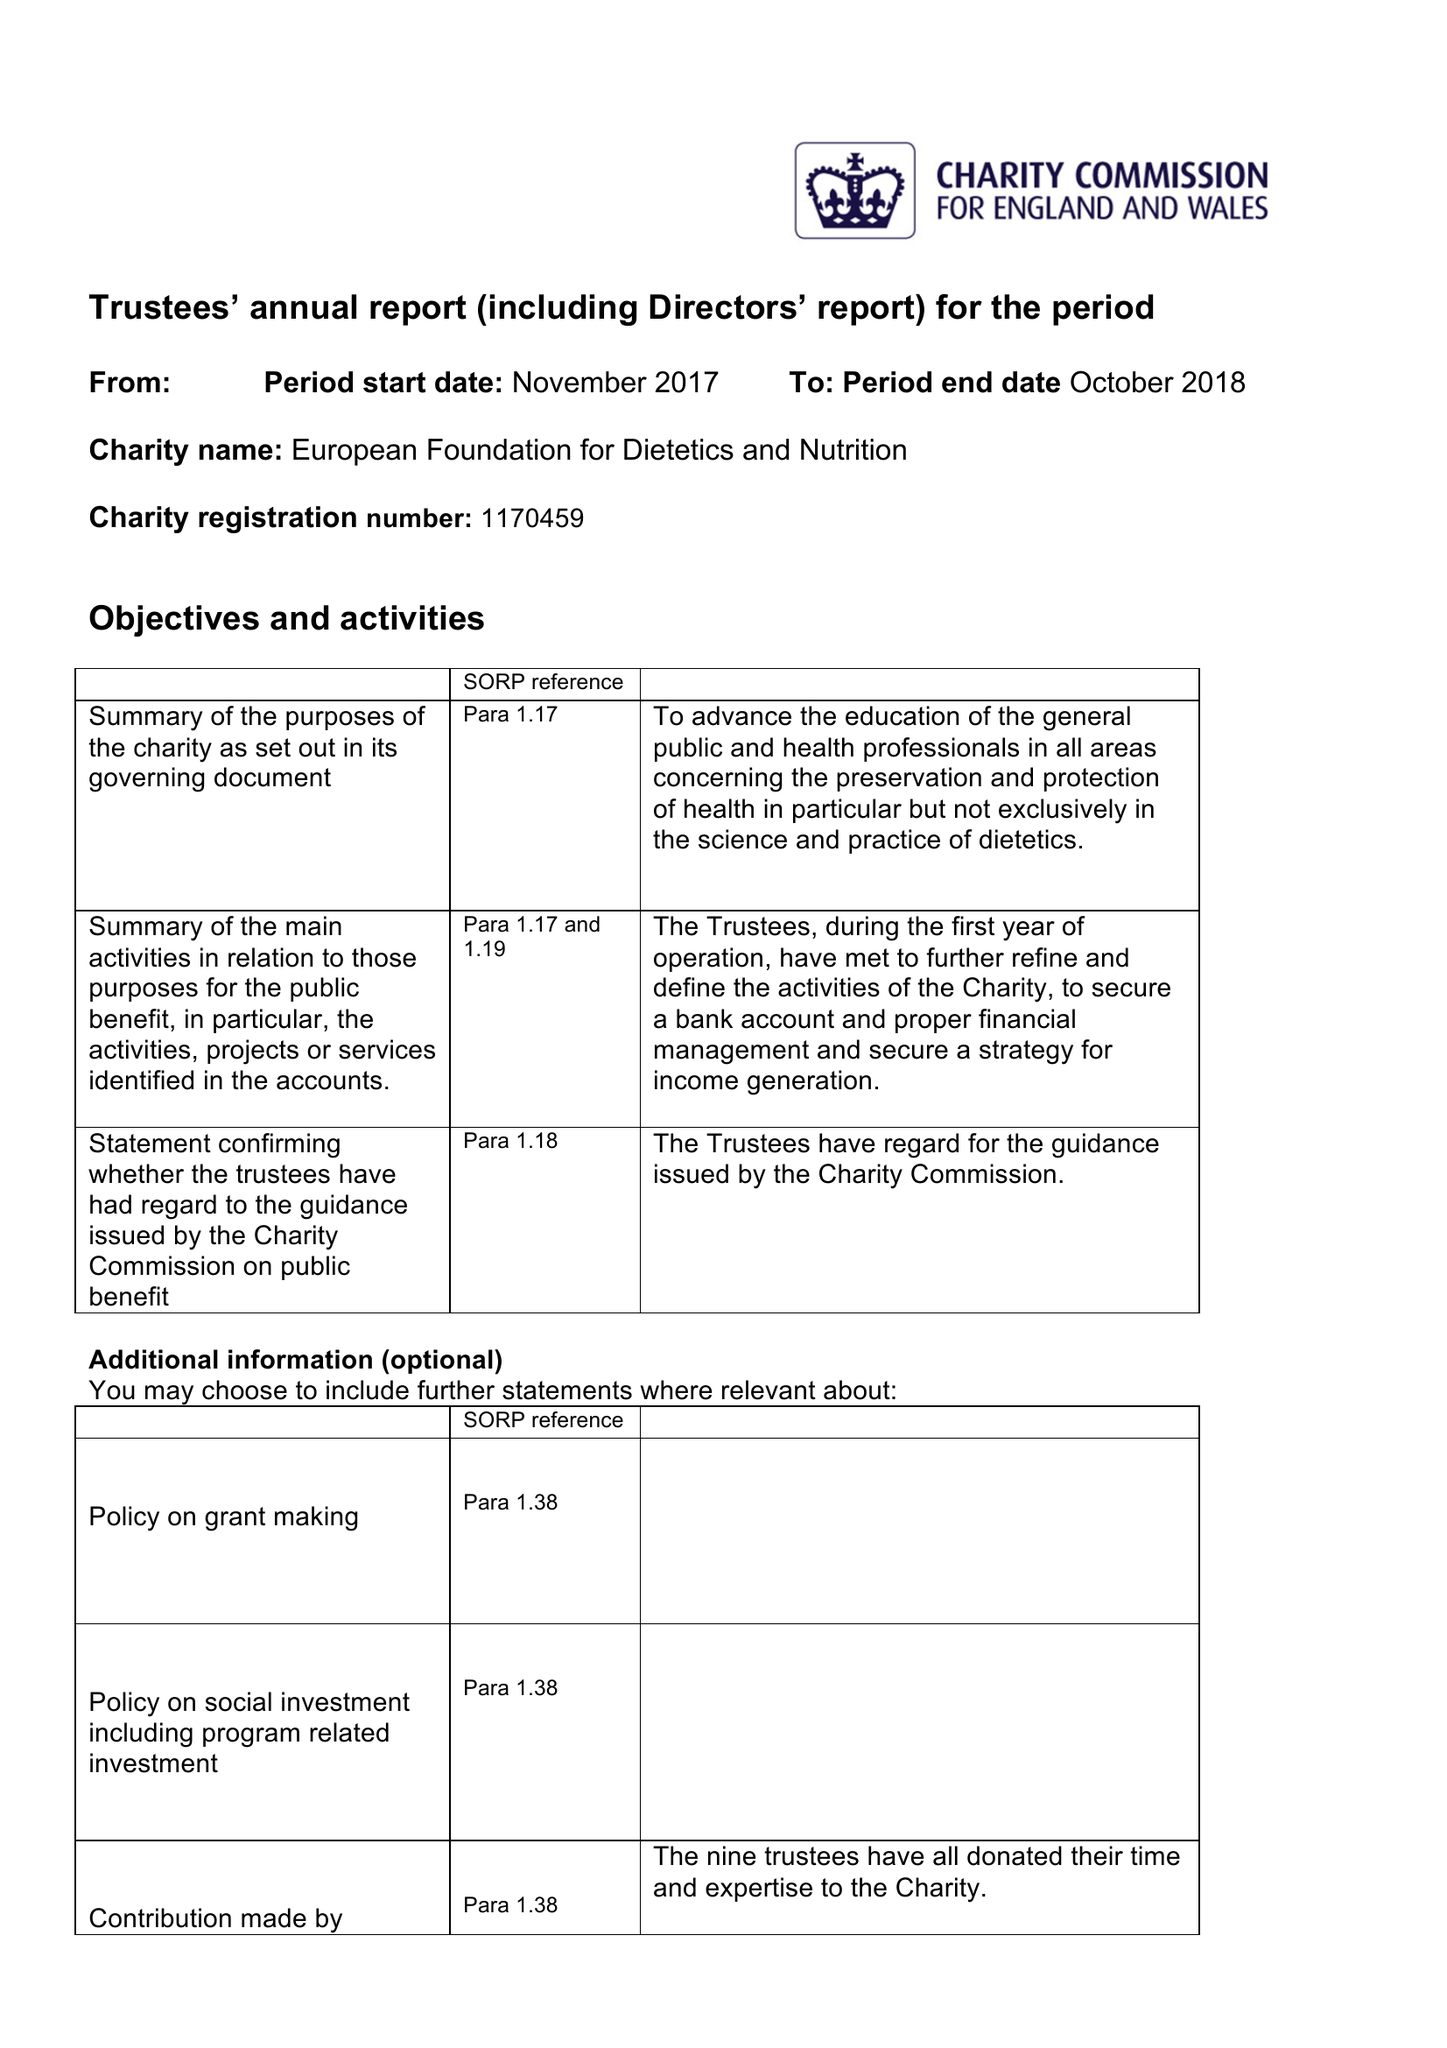What is the value for the charity_number?
Answer the question using a single word or phrase. 1170459 